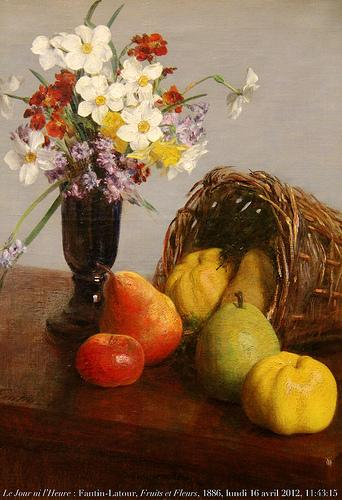Please provide a concise summary of the key elements in the image. A still life artwork shows fruits, flowers, a wooden table, a vase, and a basket with diverse colors and details. In a poetic manner, contemplate on the contents of the image. Nature's splendor unveiled, fruits and flowers bask on the wooden stage, in a vase and a basket, a harmonious display of vivid colors and life. In a casual tone, describe the main objects in the image and their relations. There's this painting with a bunch of colorful flowers and fruits chillin' on a wooden table, with a vase and a basket holding some of them. Using descriptive language, describe the fruits and flowers in the image. The image reveals a plethora of enticing, vibrant fruits and delicate flowers gracefully occupying a wooden table, with a vase and a basket cradling some of the picturesque subjects. Describe the colors and textures present in the image, focusing on the main objects. The image exhibits vibrant colors and textures, with a brown wooden table, a brown vase and basket, red and white flowers, and green and red pears and apples. Compose a brief, imaginative story based on the contents of the image. In an enchanted forest, the Spirit of Bounty placed fruits and flowers upon a wooden table, filling a vase and a basket, as a gift to the other creatures dwelling in the magical land. Using a more formal tone, describe the key objects in the image and the context in which they appear. The image illustrates a still life composition of various fruits and flowers, placed upon a wooden table, with a vase and a basket as prime components. Mention briefly the overall content of the image. The image depicts a still life painting of fruits and flowers on a wooden table, including a vase, a basket, and various fruits. Imagine you are at an art gallery, briefly explain the painting to a friend who cannot see it. This painting features a still life scene with a variety of nice flowers and fruits gathered on a wooden table, with a vase holding some flowers and a basket full of fruits. Narrate the appearance of the fruits and flowers within the image. In the artwork, there are lovely red and white flowers in a vase, and a bunch of red apples, green pears and other colorful fruits resting in a basket and on the table. 